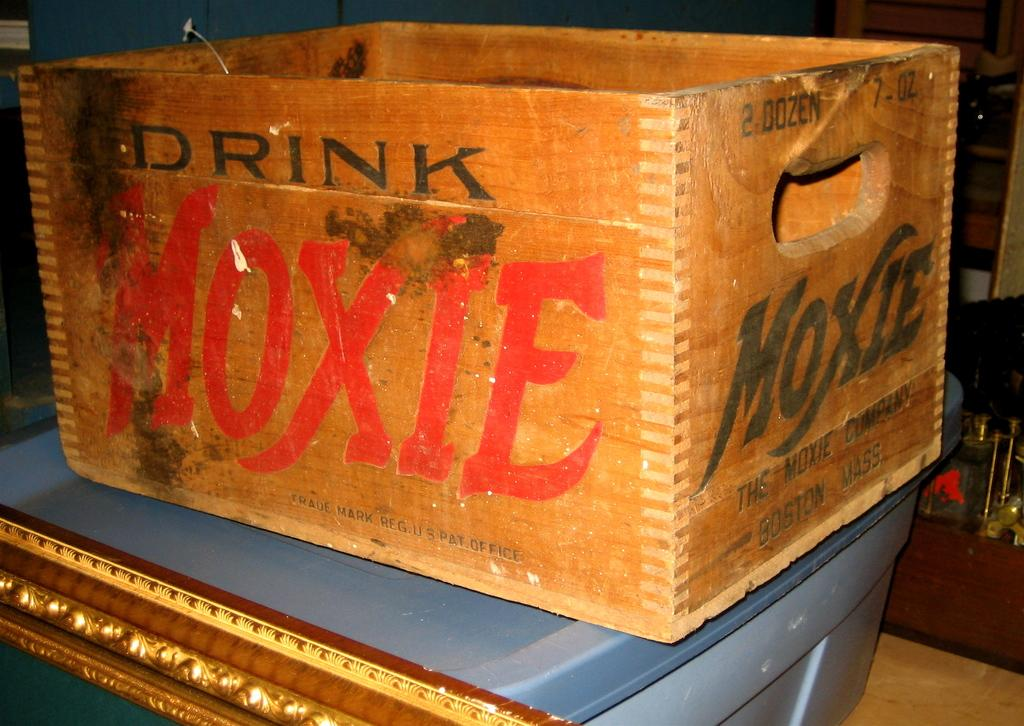<image>
Write a terse but informative summary of the picture. Wooden box that says the word MOXIE in red on it. 